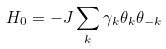<formula> <loc_0><loc_0><loc_500><loc_500>H _ { 0 } = - J \sum _ { k } \gamma _ { k } \theta _ { k } \theta _ { - k }</formula> 